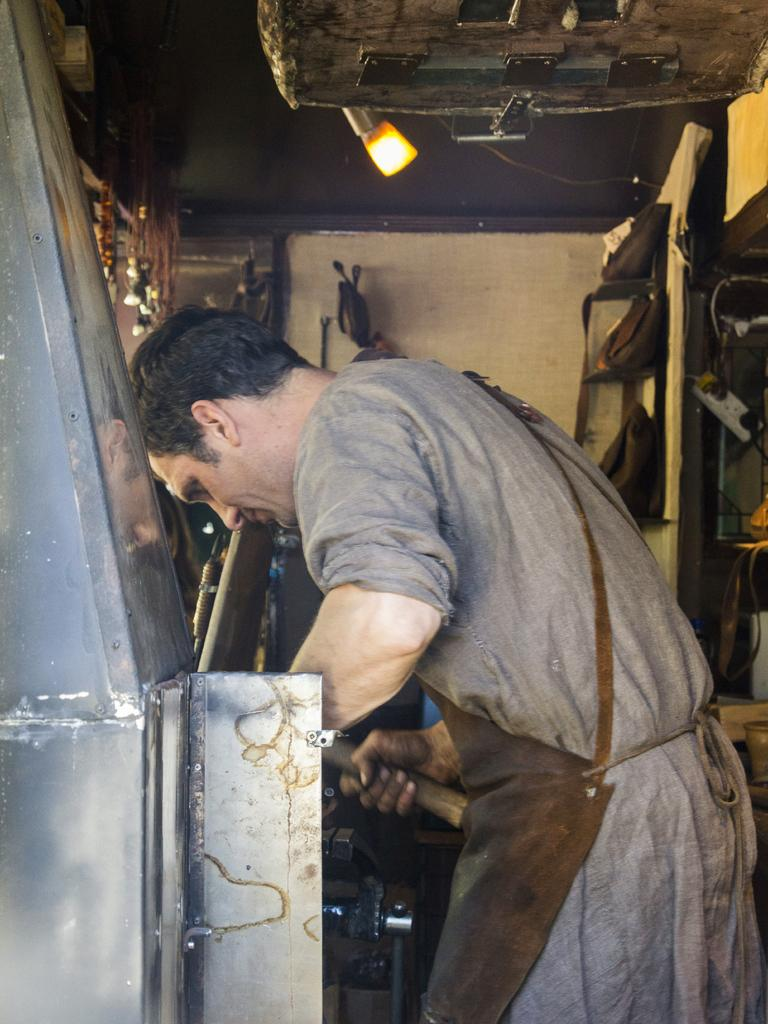What is the man in the image doing? The man is standing in the image. What is the man holding in his hand? The man is holding something in his hand. What can be seen in the background of the image? There is a wall in the background of the image. What items are visible in the image besides the man? There are bags visible in the image. What source of illumination is present in the image? There is a light in the image. What is the name of the desk in the image? There is no desk present in the image. What type of flag is being waved by the man in the image? The man in the image is not waving a flag; he is holding something else. 